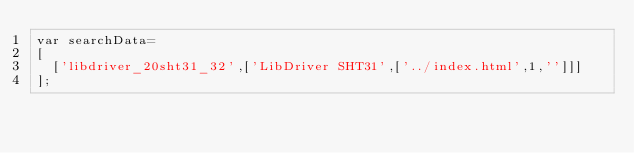<code> <loc_0><loc_0><loc_500><loc_500><_JavaScript_>var searchData=
[
  ['libdriver_20sht31_32',['LibDriver SHT31',['../index.html',1,'']]]
];
</code> 